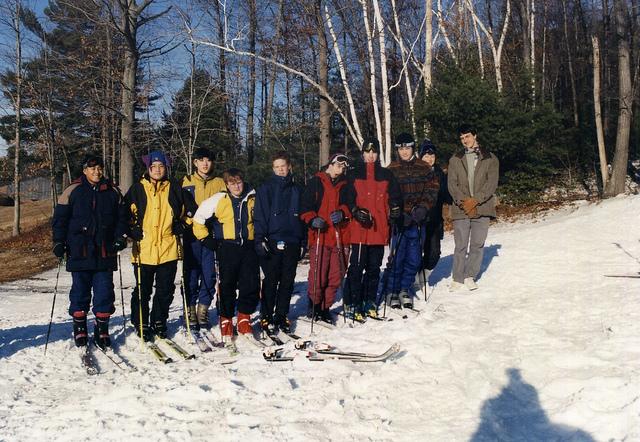What are these people doing?
Answer briefly. Skiing. Is it cold out?
Quick response, please. Yes. What are the people holding?
Give a very brief answer. Ski poles. 